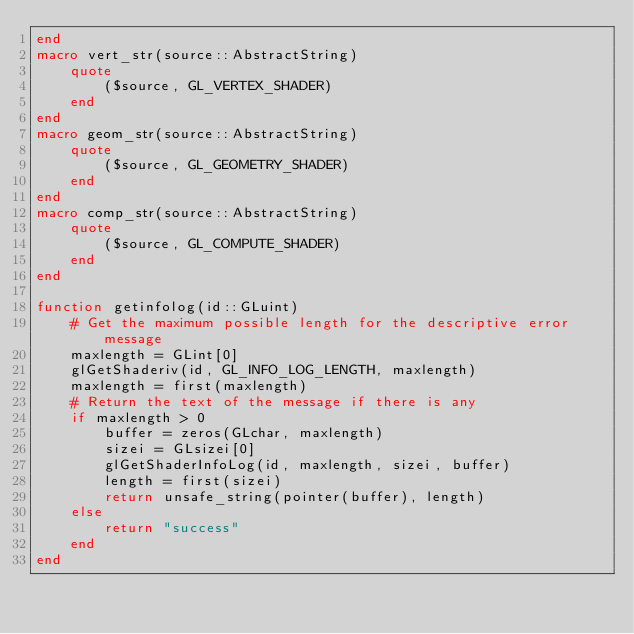Convert code to text. <code><loc_0><loc_0><loc_500><loc_500><_Julia_>end
macro vert_str(source::AbstractString)
    quote
        ($source, GL_VERTEX_SHADER)
    end
end
macro geom_str(source::AbstractString)
    quote
        ($source, GL_GEOMETRY_SHADER)
    end
end
macro comp_str(source::AbstractString)
    quote
        ($source, GL_COMPUTE_SHADER)
    end
end

function getinfolog(id::GLuint)
    # Get the maximum possible length for the descriptive error message
    maxlength = GLint[0]
    glGetShaderiv(id, GL_INFO_LOG_LENGTH, maxlength)
    maxlength = first(maxlength)
    # Return the text of the message if there is any
    if maxlength > 0
        buffer = zeros(GLchar, maxlength)
        sizei = GLsizei[0]
        glGetShaderInfoLog(id, maxlength, sizei, buffer)
        length = first(sizei)
        return unsafe_string(pointer(buffer), length)
    else
        return "success"
    end
end
</code> 